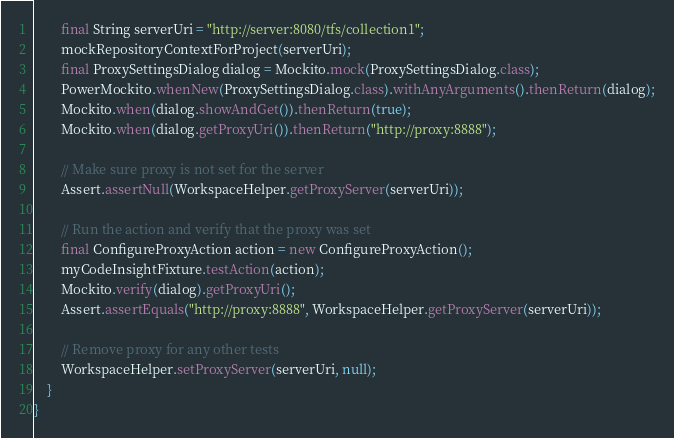Convert code to text. <code><loc_0><loc_0><loc_500><loc_500><_Java_>        final String serverUri = "http://server:8080/tfs/collection1";
        mockRepositoryContextForProject(serverUri);
        final ProxySettingsDialog dialog = Mockito.mock(ProxySettingsDialog.class);
        PowerMockito.whenNew(ProxySettingsDialog.class).withAnyArguments().thenReturn(dialog);
        Mockito.when(dialog.showAndGet()).thenReturn(true);
        Mockito.when(dialog.getProxyUri()).thenReturn("http://proxy:8888");

        // Make sure proxy is not set for the server
        Assert.assertNull(WorkspaceHelper.getProxyServer(serverUri));

        // Run the action and verify that the proxy was set
        final ConfigureProxyAction action = new ConfigureProxyAction();
        myCodeInsightFixture.testAction(action);
        Mockito.verify(dialog).getProxyUri();
        Assert.assertEquals("http://proxy:8888", WorkspaceHelper.getProxyServer(serverUri));

        // Remove proxy for any other tests
        WorkspaceHelper.setProxyServer(serverUri, null);
    }
}</code> 